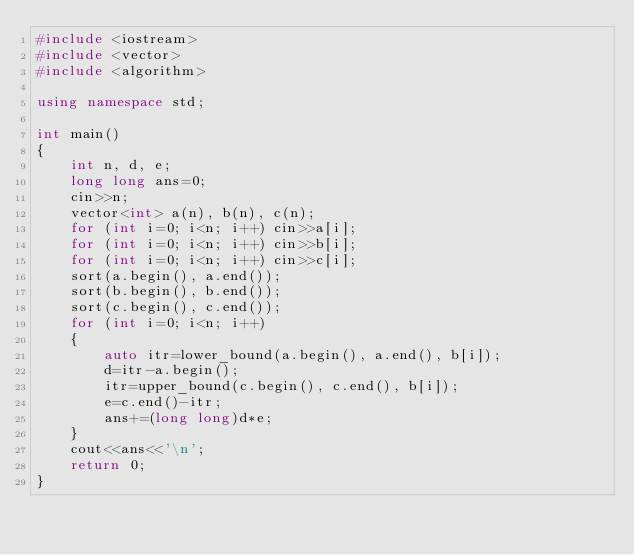<code> <loc_0><loc_0><loc_500><loc_500><_C++_>#include <iostream>
#include <vector>
#include <algorithm>

using namespace std;

int main()
{
    int n, d, e;
    long long ans=0;
    cin>>n;
    vector<int> a(n), b(n), c(n);
    for (int i=0; i<n; i++) cin>>a[i];
    for (int i=0; i<n; i++) cin>>b[i];
    for (int i=0; i<n; i++) cin>>c[i];
    sort(a.begin(), a.end());
    sort(b.begin(), b.end());
    sort(c.begin(), c.end());
    for (int i=0; i<n; i++)
    {
        auto itr=lower_bound(a.begin(), a.end(), b[i]);
        d=itr-a.begin();
        itr=upper_bound(c.begin(), c.end(), b[i]);
        e=c.end()-itr;
        ans+=(long long)d*e;
    }
    cout<<ans<<'\n';
    return 0;
}
</code> 